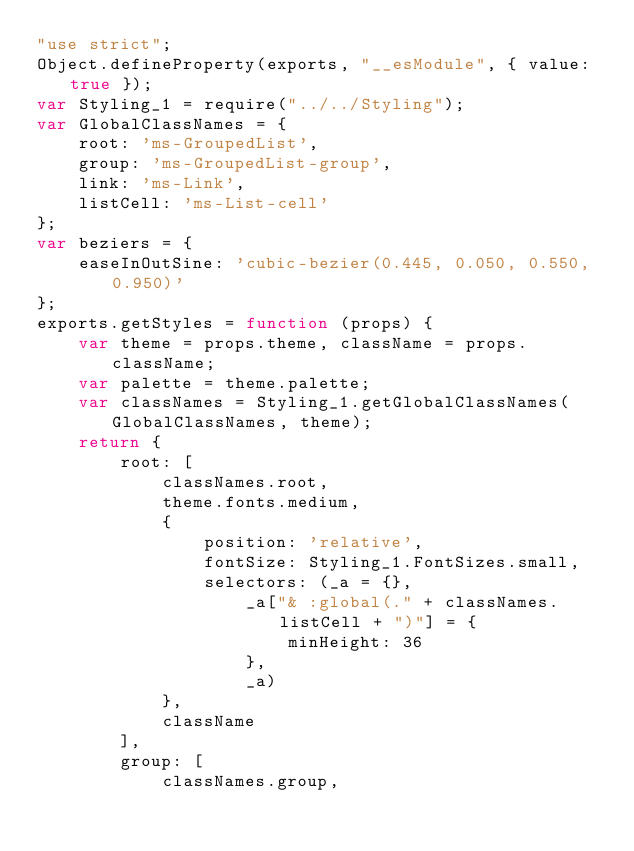Convert code to text. <code><loc_0><loc_0><loc_500><loc_500><_JavaScript_>"use strict";
Object.defineProperty(exports, "__esModule", { value: true });
var Styling_1 = require("../../Styling");
var GlobalClassNames = {
    root: 'ms-GroupedList',
    group: 'ms-GroupedList-group',
    link: 'ms-Link',
    listCell: 'ms-List-cell'
};
var beziers = {
    easeInOutSine: 'cubic-bezier(0.445, 0.050, 0.550, 0.950)'
};
exports.getStyles = function (props) {
    var theme = props.theme, className = props.className;
    var palette = theme.palette;
    var classNames = Styling_1.getGlobalClassNames(GlobalClassNames, theme);
    return {
        root: [
            classNames.root,
            theme.fonts.medium,
            {
                position: 'relative',
                fontSize: Styling_1.FontSizes.small,
                selectors: (_a = {},
                    _a["& :global(." + classNames.listCell + ")"] = {
                        minHeight: 36
                    },
                    _a)
            },
            className
        ],
        group: [
            classNames.group,</code> 